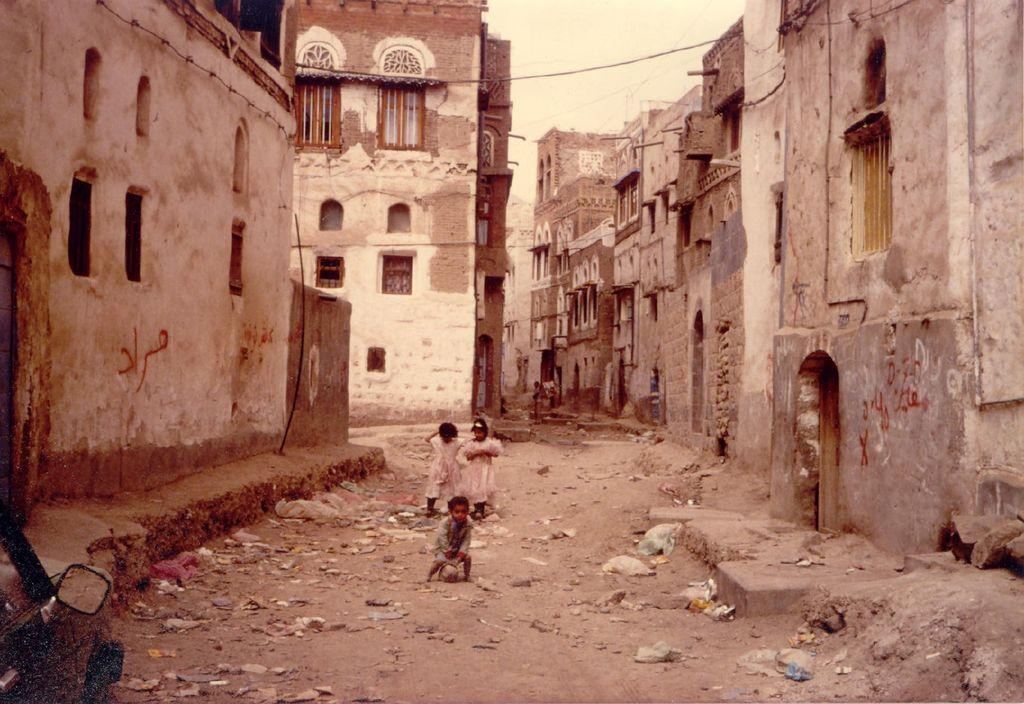How many children are standing in the image? There are three children standing in the image. What type of structures can be seen in the background? There are buildings with windows and doors in the image. What type of litter is visible on the road? Polythene bags and papers are visible on the road. Are there any other objects present on the road? Yes, there are other unspecified objects on the road. What type of crayon is being used by the cattle in the image? There are no cattle or crayons present in the image. How tall are the giants standing next to the children in the image? There are no giants present in the image. 